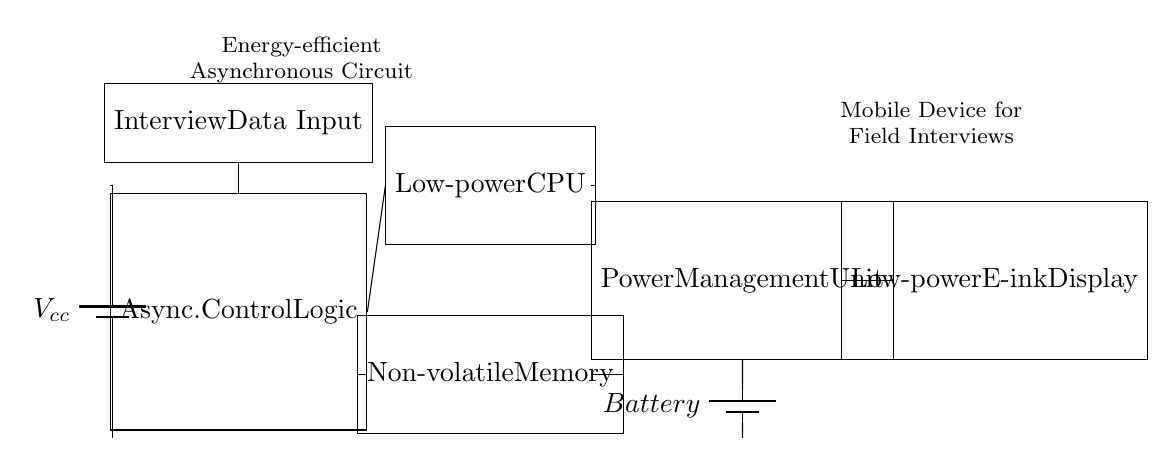What is the main purpose of the circuit? The circuit is designed for energy-efficient power management to support mobile devices used for field interviews and data collection.
Answer: Energy-efficient power management What component provides the primary energy source? The battery serves as the primary energy source, delivering power to the circuit.
Answer: Battery How many data input components are present in the circuit? There is one interview data input component in the circuit, as indicated by the labeled rectangle.
Answer: One Which component is responsible for controlling the circuit's operations? The asynchronous control logic manages the operations of the circuit and coordinates the functioning of other components.
Answer: Asynchronous control logic Name the type of display used in this circuit. The circuit utilizes a low-power E-ink display for output purposes.
Answer: Low-power E-ink display What is the function of the Power Management Unit? The Power Management Unit regulates power distribution from the battery to other components, ensuring energy efficiency and prolonging battery life.
Answer: Regulates power distribution What type of memory is specified in the circuit layout? The circuit specifies non-volatile memory, which retains information even when power is turned off.
Answer: Non-volatile memory 